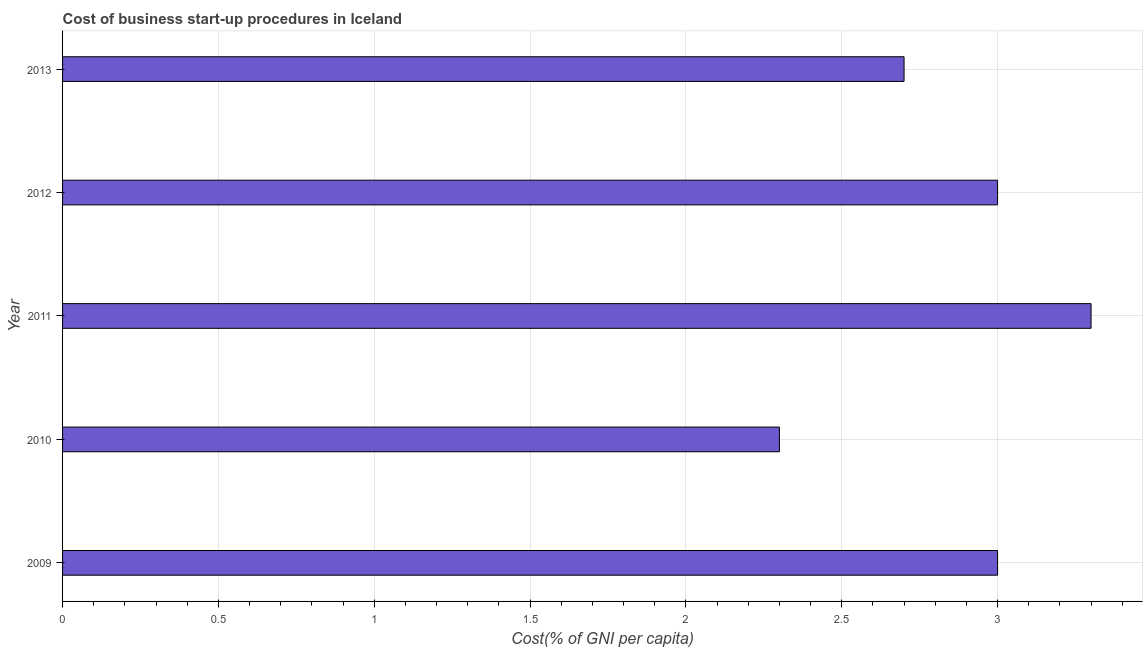Does the graph contain any zero values?
Keep it short and to the point. No. What is the title of the graph?
Your response must be concise. Cost of business start-up procedures in Iceland. What is the label or title of the X-axis?
Ensure brevity in your answer.  Cost(% of GNI per capita). What is the label or title of the Y-axis?
Make the answer very short. Year. What is the average cost of business startup procedures per year?
Your response must be concise. 2.86. What is the ratio of the cost of business startup procedures in 2009 to that in 2012?
Keep it short and to the point. 1. In how many years, is the cost of business startup procedures greater than the average cost of business startup procedures taken over all years?
Your answer should be compact. 3. How many years are there in the graph?
Ensure brevity in your answer.  5. What is the difference between two consecutive major ticks on the X-axis?
Make the answer very short. 0.5. Are the values on the major ticks of X-axis written in scientific E-notation?
Your response must be concise. No. What is the Cost(% of GNI per capita) in 2010?
Make the answer very short. 2.3. What is the Cost(% of GNI per capita) of 2011?
Offer a terse response. 3.3. What is the difference between the Cost(% of GNI per capita) in 2009 and 2010?
Provide a short and direct response. 0.7. What is the difference between the Cost(% of GNI per capita) in 2009 and 2011?
Your answer should be compact. -0.3. What is the difference between the Cost(% of GNI per capita) in 2010 and 2011?
Your answer should be very brief. -1. What is the difference between the Cost(% of GNI per capita) in 2010 and 2013?
Make the answer very short. -0.4. What is the difference between the Cost(% of GNI per capita) in 2011 and 2013?
Give a very brief answer. 0.6. What is the ratio of the Cost(% of GNI per capita) in 2009 to that in 2010?
Provide a short and direct response. 1.3. What is the ratio of the Cost(% of GNI per capita) in 2009 to that in 2011?
Give a very brief answer. 0.91. What is the ratio of the Cost(% of GNI per capita) in 2009 to that in 2013?
Provide a short and direct response. 1.11. What is the ratio of the Cost(% of GNI per capita) in 2010 to that in 2011?
Offer a very short reply. 0.7. What is the ratio of the Cost(% of GNI per capita) in 2010 to that in 2012?
Ensure brevity in your answer.  0.77. What is the ratio of the Cost(% of GNI per capita) in 2010 to that in 2013?
Offer a very short reply. 0.85. What is the ratio of the Cost(% of GNI per capita) in 2011 to that in 2013?
Give a very brief answer. 1.22. What is the ratio of the Cost(% of GNI per capita) in 2012 to that in 2013?
Offer a terse response. 1.11. 